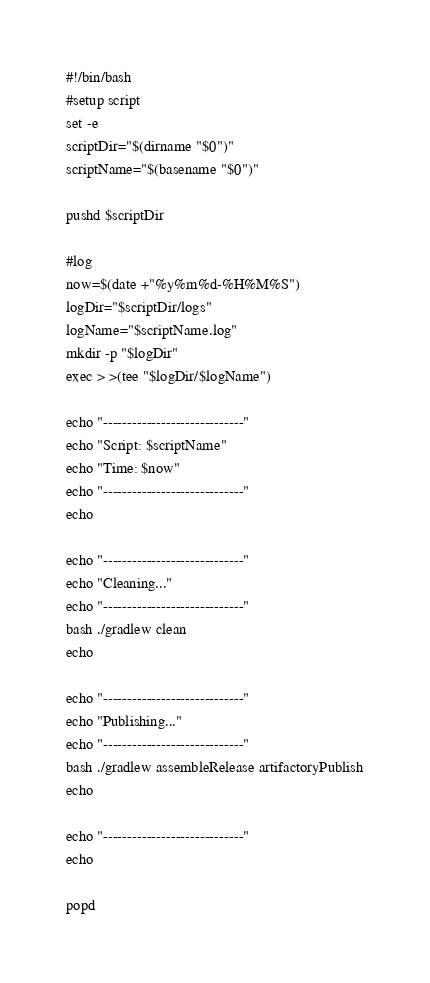<code> <loc_0><loc_0><loc_500><loc_500><_Bash_>#!/bin/bash
#setup script
set -e
scriptDir="$(dirname "$0")"
scriptName="$(basename "$0")"

pushd $scriptDir

#log
now=$(date +"%y%m%d-%H%M%S")
logDir="$scriptDir/logs"
logName="$scriptName.log"
mkdir -p "$logDir"
exec > >(tee "$logDir/$logName")

echo "-----------------------------"
echo "Script: $scriptName"
echo "Time: $now"
echo "-----------------------------"
echo

echo "-----------------------------"
echo "Cleaning..."
echo "-----------------------------"
bash ./gradlew clean 
echo

echo "-----------------------------"
echo "Publishing..."
echo "-----------------------------"
bash ./gradlew assembleRelease artifactoryPublish
echo

echo "-----------------------------"
echo

popd

</code> 